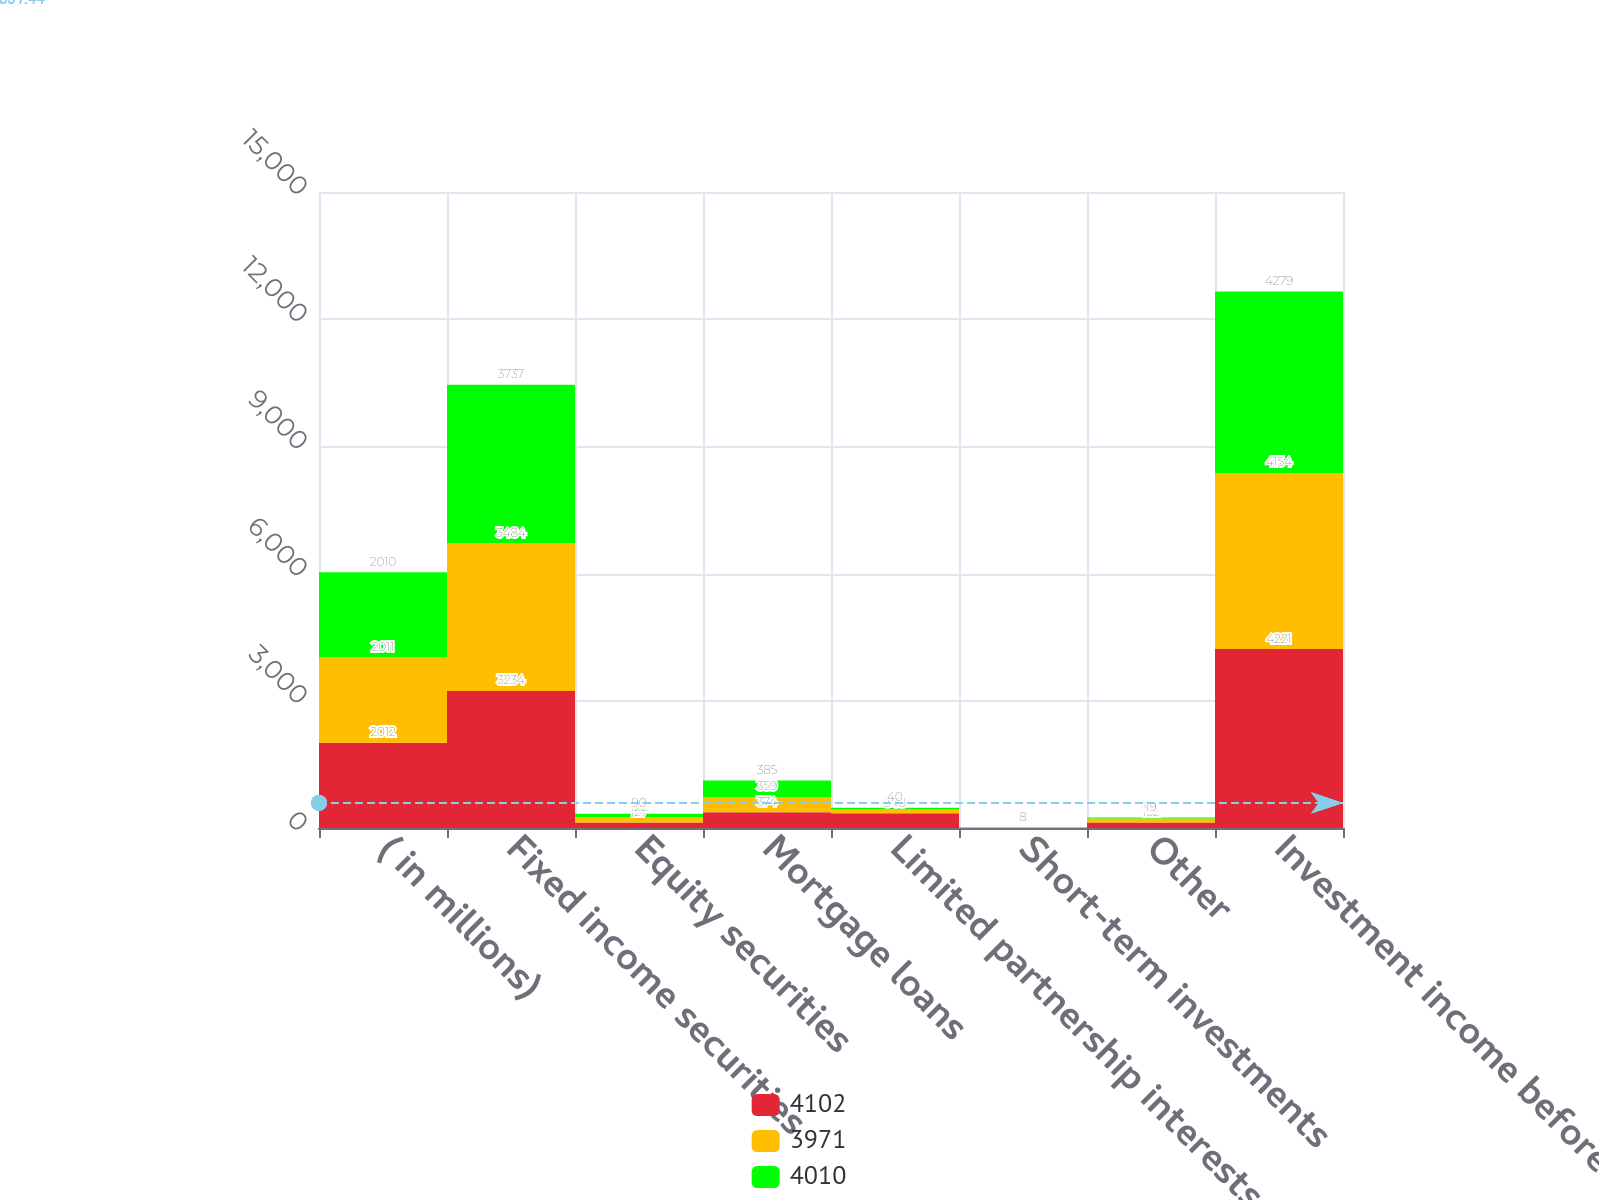<chart> <loc_0><loc_0><loc_500><loc_500><stacked_bar_chart><ecel><fcel>( in millions)<fcel>Fixed income securities<fcel>Equity securities<fcel>Mortgage loans<fcel>Limited partnership interests<fcel>Short-term investments<fcel>Other<fcel>Investment income before<nl><fcel>4102<fcel>2012<fcel>3234<fcel>127<fcel>374<fcel>348<fcel>6<fcel>132<fcel>4221<nl><fcel>3971<fcel>2011<fcel>3484<fcel>122<fcel>359<fcel>88<fcel>6<fcel>95<fcel>4154<nl><fcel>4010<fcel>2010<fcel>3737<fcel>90<fcel>385<fcel>40<fcel>8<fcel>19<fcel>4279<nl></chart> 